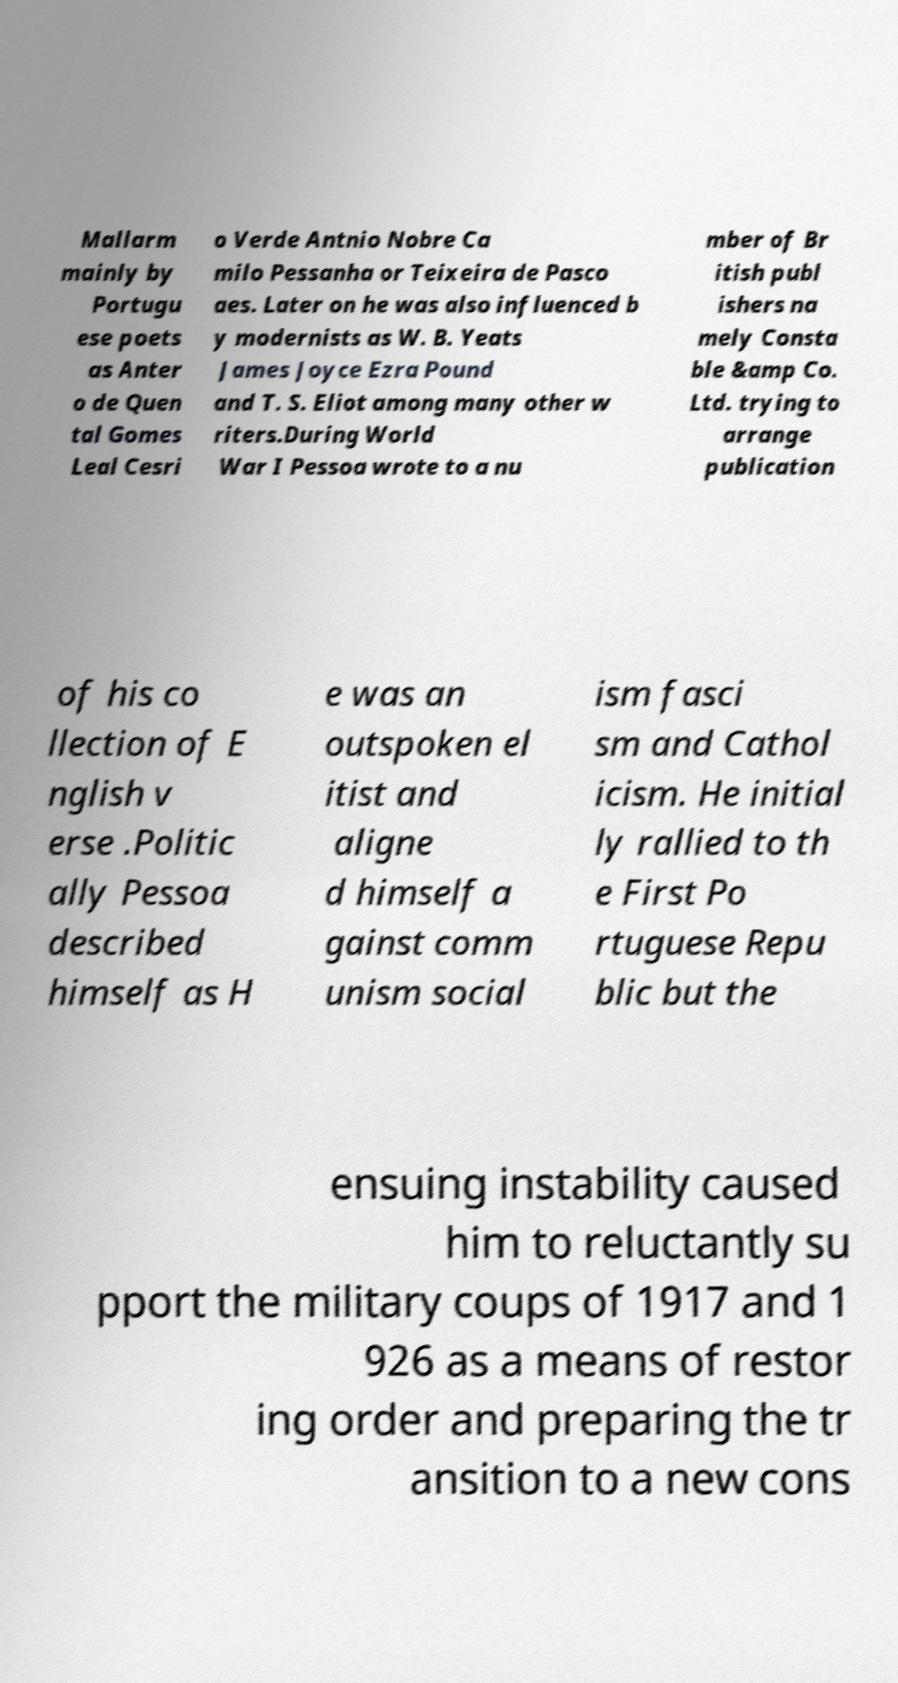Please read and relay the text visible in this image. What does it say? Mallarm mainly by Portugu ese poets as Anter o de Quen tal Gomes Leal Cesri o Verde Antnio Nobre Ca milo Pessanha or Teixeira de Pasco aes. Later on he was also influenced b y modernists as W. B. Yeats James Joyce Ezra Pound and T. S. Eliot among many other w riters.During World War I Pessoa wrote to a nu mber of Br itish publ ishers na mely Consta ble &amp Co. Ltd. trying to arrange publication of his co llection of E nglish v erse .Politic ally Pessoa described himself as H e was an outspoken el itist and aligne d himself a gainst comm unism social ism fasci sm and Cathol icism. He initial ly rallied to th e First Po rtuguese Repu blic but the ensuing instability caused him to reluctantly su pport the military coups of 1917 and 1 926 as a means of restor ing order and preparing the tr ansition to a new cons 